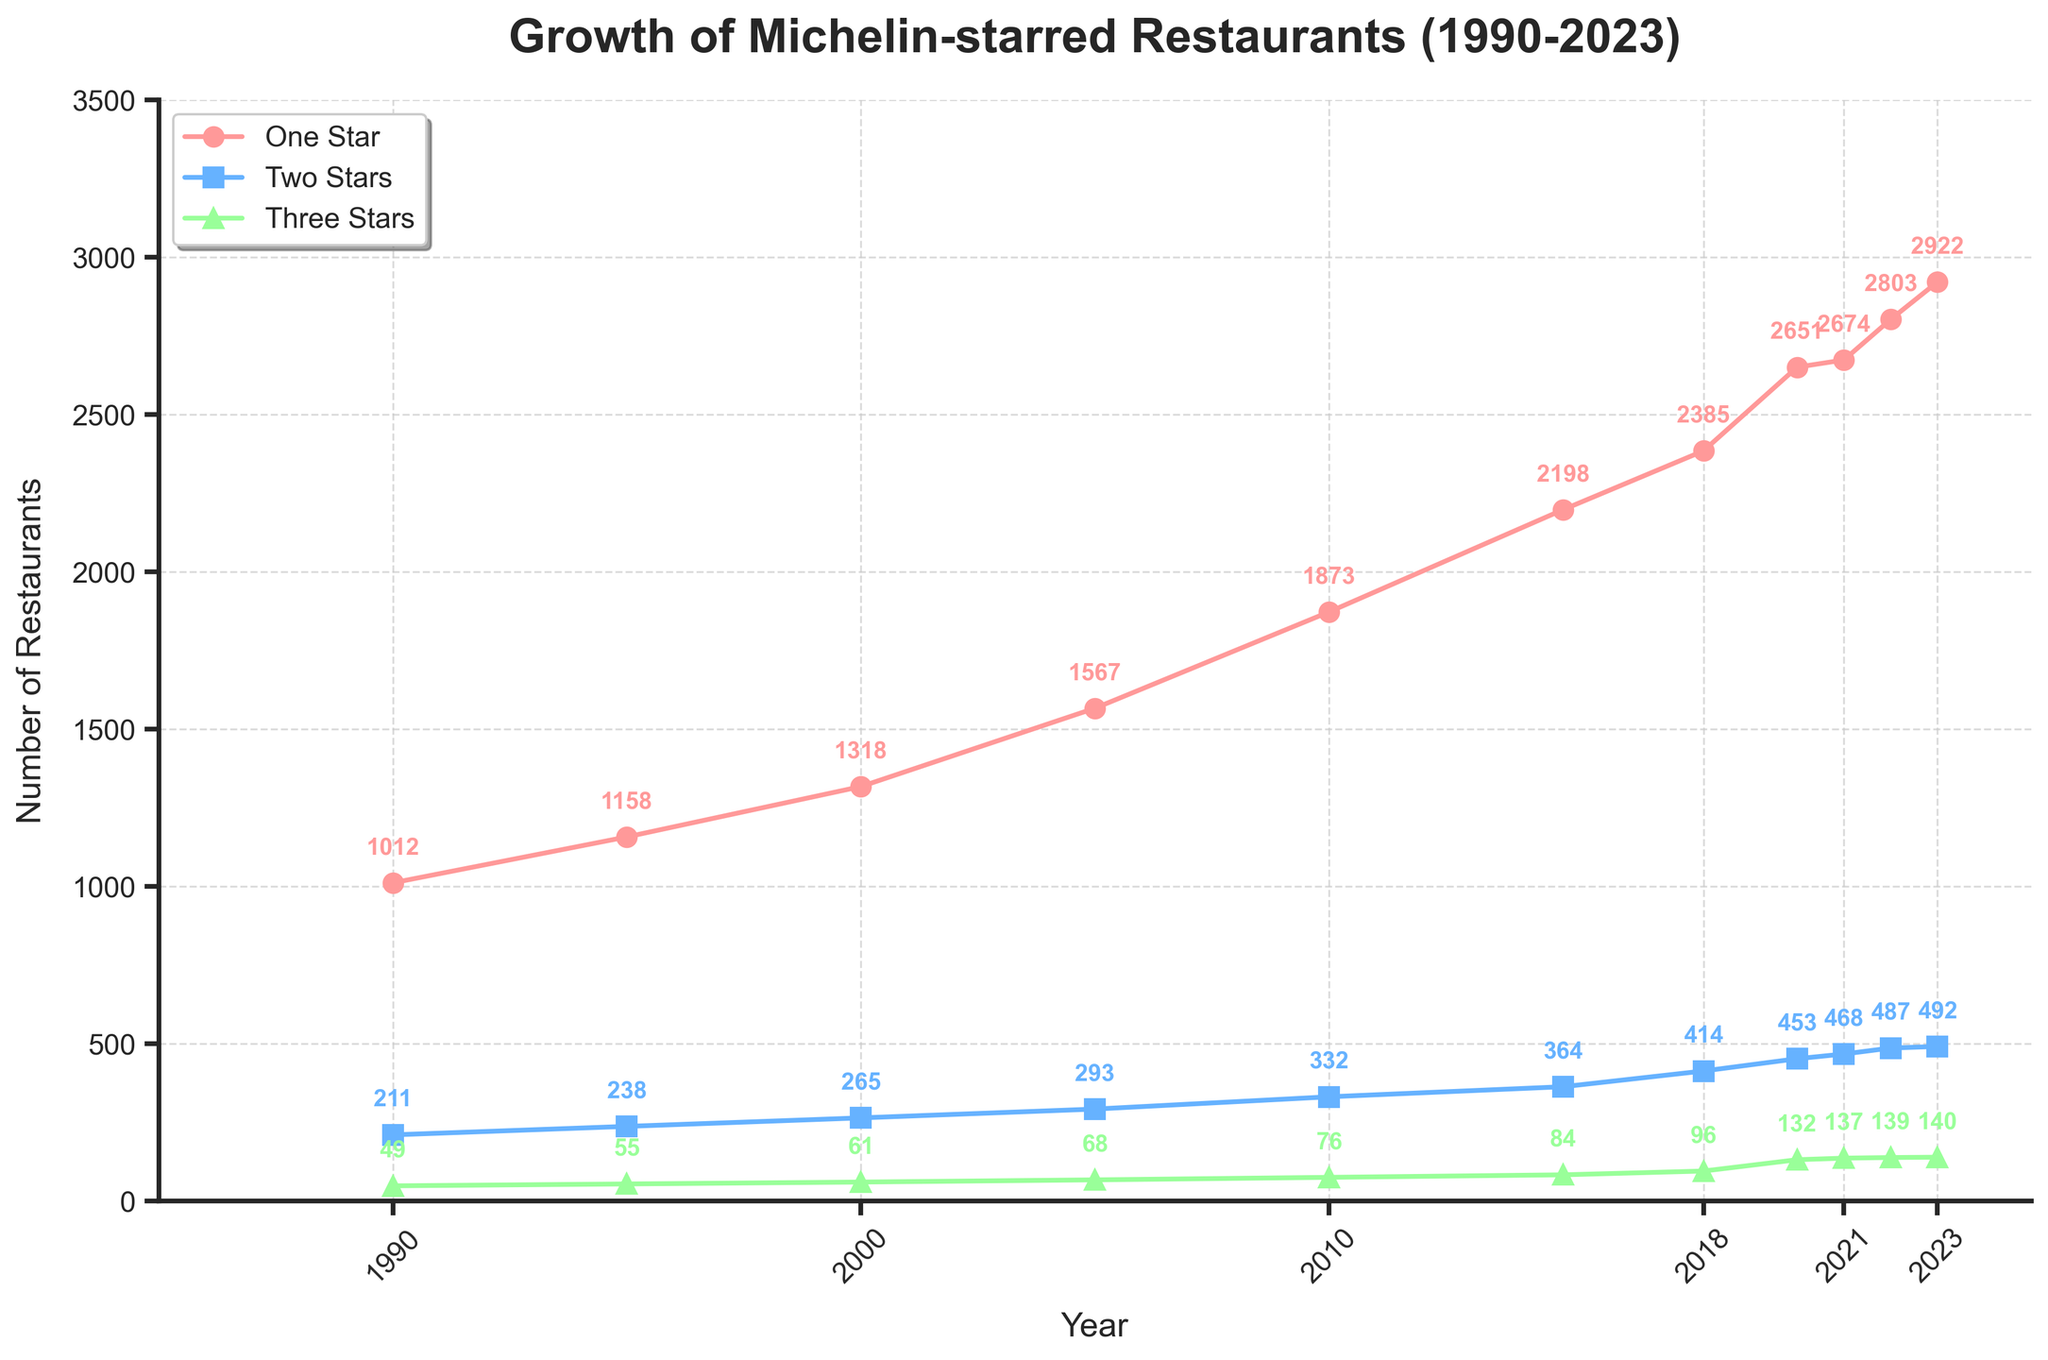Which star rating saw the largest increase in the number of Michelin-starred restaurants from 1990 to 2023? First, find the number of restaurants in 1990 and 2023 for each star category. For One Star, the increase is 2922 - 1012 = 1910. For Two Stars, it's 492 - 238 = 254. For Three Stars, it's 140 - 49 = 91. Among these, the largest increase is for One Star.
Answer: One Star By how many restaurants did the number of Two-Star Michelin restaurants change from 2018 to 2023? Find the number of Two-Star restaurants in 2018 (414) and 2023 (492), then find the difference: 492 - 414 = 78.
Answer: 78 In which year did the number of Three-Star Michelin restaurants first exceed 100? Locate the year where the number of Three-Star restaurants first goes beyond 100 by scanning the data points. This happened in 2018 with 96 Three-Star restaurants, and 132 in 2020. So, it’s 2020.
Answer: 2020 Which star category has the slowest growth trend over the period from 1990 to 2023? Calculate the overall increase for each category (One Star: 1910, Two Stars: 254, Three Stars: 91). The smallest increase is for Three Stars, indicating the slowest growth trend.
Answer: Three Stars What was the total number of Michelin-starred restaurants in 2010? Sum the number of restaurants in each category for the year 2010: 1873 (One Star) + 332 (Two Stars) + 76 (Three Stars), which equals 2281.
Answer: 2281 Compare the growth rate of One-Star and Two-Star Michelin restaurants between 2005 and 2023. Which one had the higher growth rate? For One Star: (2922 - 1567) = 1355. For Two Stars: (492 - 293) = 199. To find the growth rate, divide the increase by the initial value. One Star growth rate is 1355/1567 ≈ 0.865, and Two Stars growth rate is 199/293 ≈ 0.679. One Star had a higher growth rate.
Answer: One Star By how much did the number of Michelin-starred restaurants increase from 2000 to 2005 for the One-Star category? Find the number of One-Star restaurants in 2005 (1567) and 2000 (1318), then find the difference: 1567 - 1318 = 249.
Answer: 249 Which year experienced the highest increase in the number of Three-Star Michelin restaurants compared to the previous recorded year? Check all the yearly increments: 1995 (55 - 49 = 6), 2000 (61 - 55 = 6), 2005 (68 - 61 = 7), 2010 (76 - 68 = 8), 2015 (84 - 76 = 8), 2018 (96 - 84 = 12), 2020 (132 - 96 = 36), 2021 (137 - 132 = 5), 2022 (139 - 137 = 2), 2023 (140 - 139 = 1). The highest increase is 2020 (36).
Answer: 2020 In which year did the number of One-Star Michelin restaurants see the smallest increase compared to the previous recorded year, excluding the initial recorded year? Check all the yearly increments: 1995 (1158 - 1012 = 146), 2000 (1318 - 1158 = 160), 2005 (1567 - 1318 = 249), 2010 (1873 - 1567 = 306), 2015 (2198 - 1873 = 325), 2018 (2385 - 2198 = 187), 2020 (2651 - 2385 = 266), 2021 (2674 - 2651 = 23), 2022 (2803 - 2674 = 129), 2023 (2922 - 2803 = 119). The smallest increase is 2021 (23).
Answer: 2021 